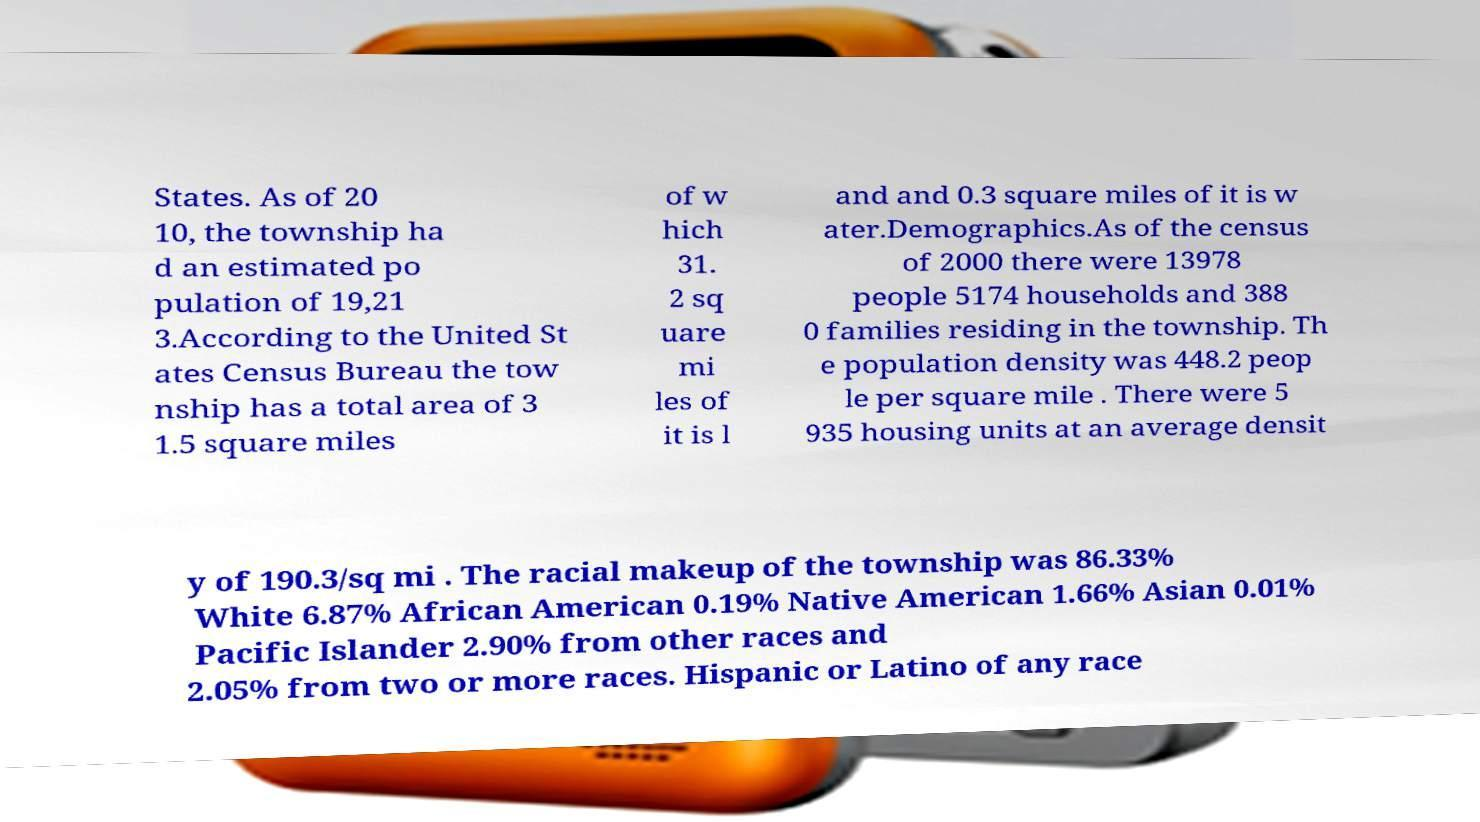For documentation purposes, I need the text within this image transcribed. Could you provide that? States. As of 20 10, the township ha d an estimated po pulation of 19,21 3.According to the United St ates Census Bureau the tow nship has a total area of 3 1.5 square miles of w hich 31. 2 sq uare mi les of it is l and and 0.3 square miles of it is w ater.Demographics.As of the census of 2000 there were 13978 people 5174 households and 388 0 families residing in the township. Th e population density was 448.2 peop le per square mile . There were 5 935 housing units at an average densit y of 190.3/sq mi . The racial makeup of the township was 86.33% White 6.87% African American 0.19% Native American 1.66% Asian 0.01% Pacific Islander 2.90% from other races and 2.05% from two or more races. Hispanic or Latino of any race 